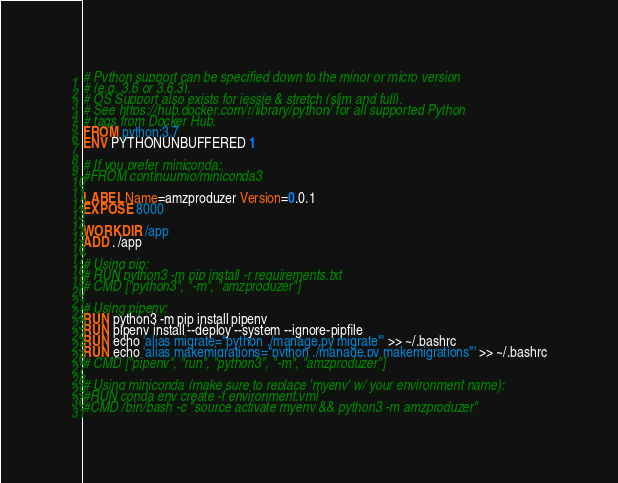<code> <loc_0><loc_0><loc_500><loc_500><_Dockerfile_># Python support can be specified down to the minor or micro version
# (e.g. 3.6 or 3.6.3).
# OS Support also exists for jessie & stretch (slim and full).
# See https://hub.docker.com/r/library/python/ for all supported Python
# tags from Docker Hub.
FROM python:3.7
ENV PYTHONUNBUFFERED 1

# If you prefer miniconda:
#FROM continuumio/miniconda3

LABEL Name=amzproduzer Version=0.0.1
EXPOSE 8000

WORKDIR /app
ADD . /app

# Using pip:
# RUN python3 -m pip install -r requirements.txt
# CMD ["python3", "-m", "amzproduzer"]

# Using pipenv:
RUN python3 -m pip install pipenv
RUN pipenv install --deploy --system --ignore-pipfile
RUN echo 'alias migrate="python ./manage.py migrate"' >> ~/.bashrc
RUN echo 'alias makemigrations="python ./manage.py makemigrations"' >> ~/.bashrc
# CMD ["pipenv", "run", "python3", "-m", "amzproduzer"]

# Using miniconda (make sure to replace 'myenv' w/ your environment name):
#RUN conda env create -f environment.yml
#CMD /bin/bash -c "source activate myenv && python3 -m amzproduzer"
</code> 